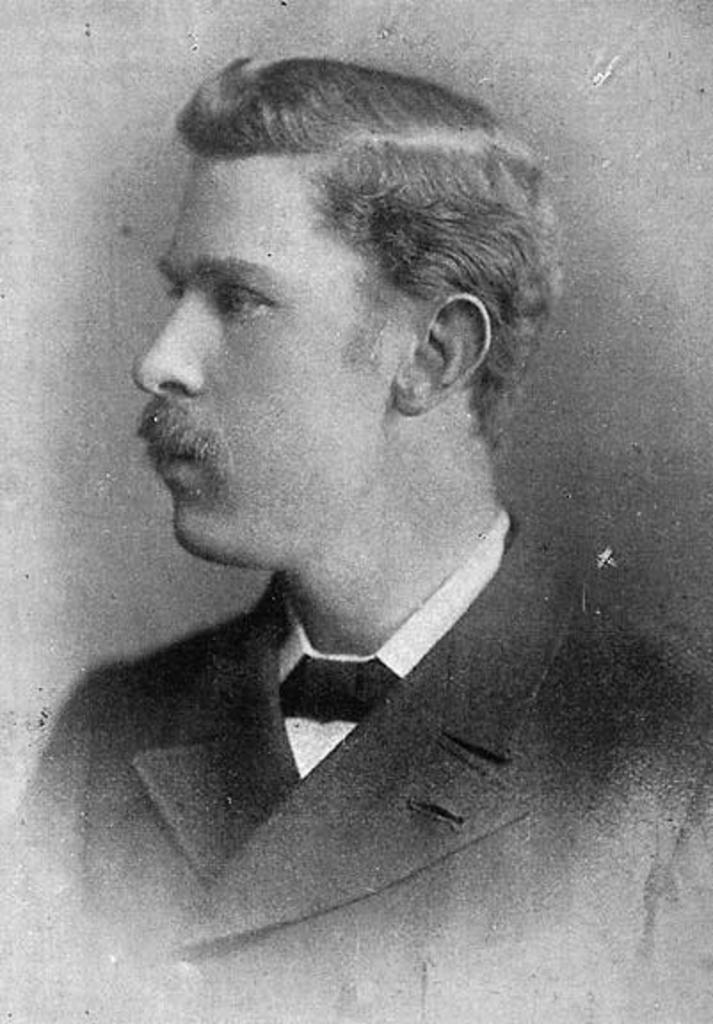In one or two sentences, can you explain what this image depicts? In this image in the front there is a man wearing black colour suit and white colour shirt and black colour tie. 